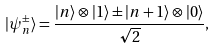<formula> <loc_0><loc_0><loc_500><loc_500>| \psi _ { n } ^ { \pm } \rangle = \frac { | n \rangle \otimes | 1 \rangle \pm | n + 1 \rangle \otimes | 0 \rangle } { \sqrt { 2 } } ,</formula> 